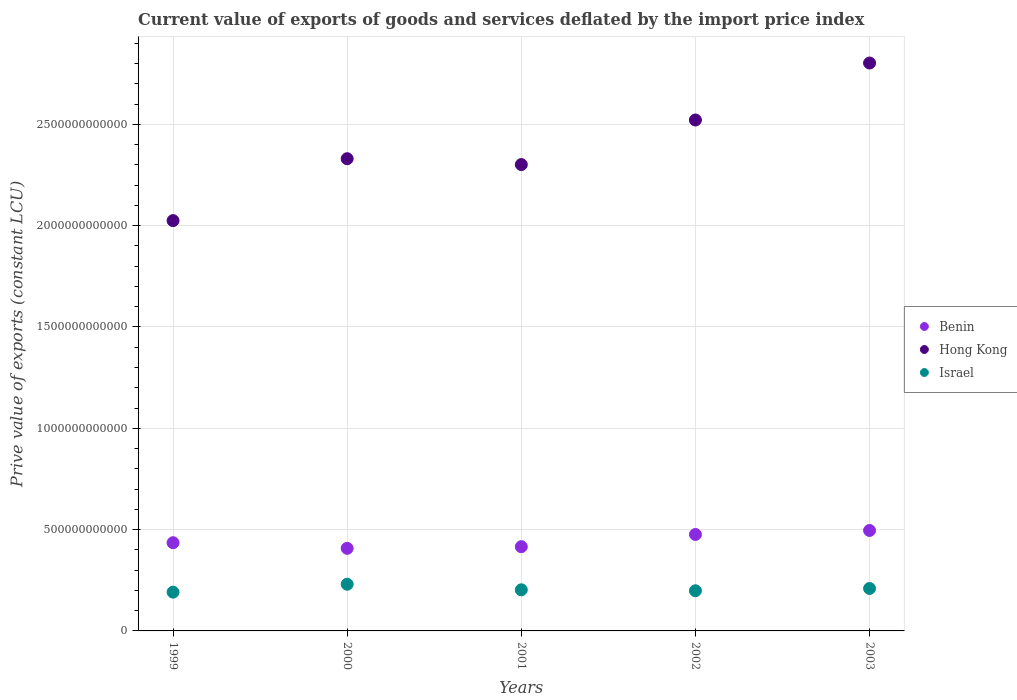What is the prive value of exports in Benin in 2001?
Give a very brief answer. 4.16e+11. Across all years, what is the maximum prive value of exports in Israel?
Offer a very short reply. 2.30e+11. Across all years, what is the minimum prive value of exports in Israel?
Your response must be concise. 1.91e+11. In which year was the prive value of exports in Benin maximum?
Ensure brevity in your answer.  2003. What is the total prive value of exports in Israel in the graph?
Provide a succinct answer. 1.03e+12. What is the difference between the prive value of exports in Benin in 2002 and that in 2003?
Keep it short and to the point. -1.97e+1. What is the difference between the prive value of exports in Hong Kong in 2002 and the prive value of exports in Benin in 2000?
Make the answer very short. 2.11e+12. What is the average prive value of exports in Israel per year?
Keep it short and to the point. 2.06e+11. In the year 2001, what is the difference between the prive value of exports in Hong Kong and prive value of exports in Israel?
Provide a short and direct response. 2.10e+12. In how many years, is the prive value of exports in Hong Kong greater than 2800000000000 LCU?
Your answer should be compact. 1. What is the ratio of the prive value of exports in Benin in 2000 to that in 2003?
Your answer should be compact. 0.82. Is the prive value of exports in Benin in 2000 less than that in 2002?
Your response must be concise. Yes. Is the difference between the prive value of exports in Hong Kong in 1999 and 2003 greater than the difference between the prive value of exports in Israel in 1999 and 2003?
Provide a succinct answer. No. What is the difference between the highest and the second highest prive value of exports in Hong Kong?
Provide a succinct answer. 2.81e+11. What is the difference between the highest and the lowest prive value of exports in Israel?
Provide a short and direct response. 3.90e+1. Is it the case that in every year, the sum of the prive value of exports in Benin and prive value of exports in Israel  is greater than the prive value of exports in Hong Kong?
Offer a terse response. No. Does the prive value of exports in Benin monotonically increase over the years?
Provide a succinct answer. No. Is the prive value of exports in Hong Kong strictly greater than the prive value of exports in Benin over the years?
Provide a succinct answer. Yes. What is the difference between two consecutive major ticks on the Y-axis?
Give a very brief answer. 5.00e+11. Does the graph contain any zero values?
Your response must be concise. No. Does the graph contain grids?
Your answer should be compact. Yes. Where does the legend appear in the graph?
Keep it short and to the point. Center right. How many legend labels are there?
Make the answer very short. 3. How are the legend labels stacked?
Your answer should be very brief. Vertical. What is the title of the graph?
Ensure brevity in your answer.  Current value of exports of goods and services deflated by the import price index. What is the label or title of the X-axis?
Your response must be concise. Years. What is the label or title of the Y-axis?
Your response must be concise. Prive value of exports (constant LCU). What is the Prive value of exports (constant LCU) of Benin in 1999?
Provide a succinct answer. 4.35e+11. What is the Prive value of exports (constant LCU) of Hong Kong in 1999?
Your answer should be compact. 2.02e+12. What is the Prive value of exports (constant LCU) of Israel in 1999?
Your response must be concise. 1.91e+11. What is the Prive value of exports (constant LCU) in Benin in 2000?
Offer a terse response. 4.08e+11. What is the Prive value of exports (constant LCU) in Hong Kong in 2000?
Give a very brief answer. 2.33e+12. What is the Prive value of exports (constant LCU) of Israel in 2000?
Provide a short and direct response. 2.30e+11. What is the Prive value of exports (constant LCU) of Benin in 2001?
Offer a very short reply. 4.16e+11. What is the Prive value of exports (constant LCU) of Hong Kong in 2001?
Offer a very short reply. 2.30e+12. What is the Prive value of exports (constant LCU) in Israel in 2001?
Provide a short and direct response. 2.03e+11. What is the Prive value of exports (constant LCU) in Benin in 2002?
Offer a very short reply. 4.76e+11. What is the Prive value of exports (constant LCU) of Hong Kong in 2002?
Make the answer very short. 2.52e+12. What is the Prive value of exports (constant LCU) of Israel in 2002?
Keep it short and to the point. 1.98e+11. What is the Prive value of exports (constant LCU) of Benin in 2003?
Provide a succinct answer. 4.96e+11. What is the Prive value of exports (constant LCU) in Hong Kong in 2003?
Make the answer very short. 2.80e+12. What is the Prive value of exports (constant LCU) in Israel in 2003?
Offer a terse response. 2.10e+11. Across all years, what is the maximum Prive value of exports (constant LCU) of Benin?
Keep it short and to the point. 4.96e+11. Across all years, what is the maximum Prive value of exports (constant LCU) in Hong Kong?
Provide a succinct answer. 2.80e+12. Across all years, what is the maximum Prive value of exports (constant LCU) in Israel?
Your response must be concise. 2.30e+11. Across all years, what is the minimum Prive value of exports (constant LCU) in Benin?
Your answer should be very brief. 4.08e+11. Across all years, what is the minimum Prive value of exports (constant LCU) in Hong Kong?
Ensure brevity in your answer.  2.02e+12. Across all years, what is the minimum Prive value of exports (constant LCU) in Israel?
Your answer should be very brief. 1.91e+11. What is the total Prive value of exports (constant LCU) of Benin in the graph?
Ensure brevity in your answer.  2.23e+12. What is the total Prive value of exports (constant LCU) in Hong Kong in the graph?
Keep it short and to the point. 1.20e+13. What is the total Prive value of exports (constant LCU) of Israel in the graph?
Offer a very short reply. 1.03e+12. What is the difference between the Prive value of exports (constant LCU) in Benin in 1999 and that in 2000?
Ensure brevity in your answer.  2.77e+1. What is the difference between the Prive value of exports (constant LCU) in Hong Kong in 1999 and that in 2000?
Ensure brevity in your answer.  -3.05e+11. What is the difference between the Prive value of exports (constant LCU) of Israel in 1999 and that in 2000?
Offer a very short reply. -3.90e+1. What is the difference between the Prive value of exports (constant LCU) in Benin in 1999 and that in 2001?
Offer a terse response. 1.96e+1. What is the difference between the Prive value of exports (constant LCU) of Hong Kong in 1999 and that in 2001?
Ensure brevity in your answer.  -2.77e+11. What is the difference between the Prive value of exports (constant LCU) in Israel in 1999 and that in 2001?
Offer a terse response. -1.15e+1. What is the difference between the Prive value of exports (constant LCU) of Benin in 1999 and that in 2002?
Offer a very short reply. -4.07e+1. What is the difference between the Prive value of exports (constant LCU) of Hong Kong in 1999 and that in 2002?
Your answer should be compact. -4.96e+11. What is the difference between the Prive value of exports (constant LCU) in Israel in 1999 and that in 2002?
Make the answer very short. -6.76e+09. What is the difference between the Prive value of exports (constant LCU) in Benin in 1999 and that in 2003?
Offer a very short reply. -6.04e+1. What is the difference between the Prive value of exports (constant LCU) in Hong Kong in 1999 and that in 2003?
Your answer should be very brief. -7.78e+11. What is the difference between the Prive value of exports (constant LCU) of Israel in 1999 and that in 2003?
Give a very brief answer. -1.81e+1. What is the difference between the Prive value of exports (constant LCU) of Benin in 2000 and that in 2001?
Keep it short and to the point. -8.10e+09. What is the difference between the Prive value of exports (constant LCU) in Hong Kong in 2000 and that in 2001?
Give a very brief answer. 2.89e+1. What is the difference between the Prive value of exports (constant LCU) of Israel in 2000 and that in 2001?
Give a very brief answer. 2.75e+1. What is the difference between the Prive value of exports (constant LCU) of Benin in 2000 and that in 2002?
Provide a short and direct response. -6.84e+1. What is the difference between the Prive value of exports (constant LCU) of Hong Kong in 2000 and that in 2002?
Offer a very short reply. -1.91e+11. What is the difference between the Prive value of exports (constant LCU) in Israel in 2000 and that in 2002?
Your answer should be very brief. 3.22e+1. What is the difference between the Prive value of exports (constant LCU) in Benin in 2000 and that in 2003?
Your answer should be very brief. -8.81e+1. What is the difference between the Prive value of exports (constant LCU) of Hong Kong in 2000 and that in 2003?
Your answer should be compact. -4.72e+11. What is the difference between the Prive value of exports (constant LCU) of Israel in 2000 and that in 2003?
Keep it short and to the point. 2.09e+1. What is the difference between the Prive value of exports (constant LCU) in Benin in 2001 and that in 2002?
Provide a short and direct response. -6.03e+1. What is the difference between the Prive value of exports (constant LCU) in Hong Kong in 2001 and that in 2002?
Give a very brief answer. -2.20e+11. What is the difference between the Prive value of exports (constant LCU) in Israel in 2001 and that in 2002?
Make the answer very short. 4.76e+09. What is the difference between the Prive value of exports (constant LCU) in Benin in 2001 and that in 2003?
Keep it short and to the point. -8.00e+1. What is the difference between the Prive value of exports (constant LCU) in Hong Kong in 2001 and that in 2003?
Provide a succinct answer. -5.01e+11. What is the difference between the Prive value of exports (constant LCU) of Israel in 2001 and that in 2003?
Keep it short and to the point. -6.62e+09. What is the difference between the Prive value of exports (constant LCU) of Benin in 2002 and that in 2003?
Provide a succinct answer. -1.97e+1. What is the difference between the Prive value of exports (constant LCU) of Hong Kong in 2002 and that in 2003?
Keep it short and to the point. -2.81e+11. What is the difference between the Prive value of exports (constant LCU) of Israel in 2002 and that in 2003?
Your response must be concise. -1.14e+1. What is the difference between the Prive value of exports (constant LCU) of Benin in 1999 and the Prive value of exports (constant LCU) of Hong Kong in 2000?
Your answer should be compact. -1.89e+12. What is the difference between the Prive value of exports (constant LCU) in Benin in 1999 and the Prive value of exports (constant LCU) in Israel in 2000?
Your answer should be compact. 2.05e+11. What is the difference between the Prive value of exports (constant LCU) in Hong Kong in 1999 and the Prive value of exports (constant LCU) in Israel in 2000?
Provide a short and direct response. 1.79e+12. What is the difference between the Prive value of exports (constant LCU) of Benin in 1999 and the Prive value of exports (constant LCU) of Hong Kong in 2001?
Ensure brevity in your answer.  -1.87e+12. What is the difference between the Prive value of exports (constant LCU) of Benin in 1999 and the Prive value of exports (constant LCU) of Israel in 2001?
Your answer should be compact. 2.32e+11. What is the difference between the Prive value of exports (constant LCU) of Hong Kong in 1999 and the Prive value of exports (constant LCU) of Israel in 2001?
Your answer should be compact. 1.82e+12. What is the difference between the Prive value of exports (constant LCU) in Benin in 1999 and the Prive value of exports (constant LCU) in Hong Kong in 2002?
Offer a terse response. -2.09e+12. What is the difference between the Prive value of exports (constant LCU) in Benin in 1999 and the Prive value of exports (constant LCU) in Israel in 2002?
Give a very brief answer. 2.37e+11. What is the difference between the Prive value of exports (constant LCU) in Hong Kong in 1999 and the Prive value of exports (constant LCU) in Israel in 2002?
Offer a very short reply. 1.83e+12. What is the difference between the Prive value of exports (constant LCU) in Benin in 1999 and the Prive value of exports (constant LCU) in Hong Kong in 2003?
Make the answer very short. -2.37e+12. What is the difference between the Prive value of exports (constant LCU) of Benin in 1999 and the Prive value of exports (constant LCU) of Israel in 2003?
Provide a short and direct response. 2.26e+11. What is the difference between the Prive value of exports (constant LCU) of Hong Kong in 1999 and the Prive value of exports (constant LCU) of Israel in 2003?
Your answer should be very brief. 1.82e+12. What is the difference between the Prive value of exports (constant LCU) in Benin in 2000 and the Prive value of exports (constant LCU) in Hong Kong in 2001?
Make the answer very short. -1.89e+12. What is the difference between the Prive value of exports (constant LCU) in Benin in 2000 and the Prive value of exports (constant LCU) in Israel in 2001?
Offer a very short reply. 2.05e+11. What is the difference between the Prive value of exports (constant LCU) of Hong Kong in 2000 and the Prive value of exports (constant LCU) of Israel in 2001?
Provide a succinct answer. 2.13e+12. What is the difference between the Prive value of exports (constant LCU) of Benin in 2000 and the Prive value of exports (constant LCU) of Hong Kong in 2002?
Your answer should be compact. -2.11e+12. What is the difference between the Prive value of exports (constant LCU) in Benin in 2000 and the Prive value of exports (constant LCU) in Israel in 2002?
Give a very brief answer. 2.09e+11. What is the difference between the Prive value of exports (constant LCU) in Hong Kong in 2000 and the Prive value of exports (constant LCU) in Israel in 2002?
Offer a terse response. 2.13e+12. What is the difference between the Prive value of exports (constant LCU) in Benin in 2000 and the Prive value of exports (constant LCU) in Hong Kong in 2003?
Your response must be concise. -2.39e+12. What is the difference between the Prive value of exports (constant LCU) in Benin in 2000 and the Prive value of exports (constant LCU) in Israel in 2003?
Give a very brief answer. 1.98e+11. What is the difference between the Prive value of exports (constant LCU) in Hong Kong in 2000 and the Prive value of exports (constant LCU) in Israel in 2003?
Offer a very short reply. 2.12e+12. What is the difference between the Prive value of exports (constant LCU) of Benin in 2001 and the Prive value of exports (constant LCU) of Hong Kong in 2002?
Your answer should be compact. -2.11e+12. What is the difference between the Prive value of exports (constant LCU) of Benin in 2001 and the Prive value of exports (constant LCU) of Israel in 2002?
Provide a succinct answer. 2.18e+11. What is the difference between the Prive value of exports (constant LCU) in Hong Kong in 2001 and the Prive value of exports (constant LCU) in Israel in 2002?
Make the answer very short. 2.10e+12. What is the difference between the Prive value of exports (constant LCU) in Benin in 2001 and the Prive value of exports (constant LCU) in Hong Kong in 2003?
Offer a terse response. -2.39e+12. What is the difference between the Prive value of exports (constant LCU) in Benin in 2001 and the Prive value of exports (constant LCU) in Israel in 2003?
Your answer should be compact. 2.06e+11. What is the difference between the Prive value of exports (constant LCU) of Hong Kong in 2001 and the Prive value of exports (constant LCU) of Israel in 2003?
Make the answer very short. 2.09e+12. What is the difference between the Prive value of exports (constant LCU) in Benin in 2002 and the Prive value of exports (constant LCU) in Hong Kong in 2003?
Provide a succinct answer. -2.33e+12. What is the difference between the Prive value of exports (constant LCU) in Benin in 2002 and the Prive value of exports (constant LCU) in Israel in 2003?
Provide a short and direct response. 2.66e+11. What is the difference between the Prive value of exports (constant LCU) in Hong Kong in 2002 and the Prive value of exports (constant LCU) in Israel in 2003?
Ensure brevity in your answer.  2.31e+12. What is the average Prive value of exports (constant LCU) in Benin per year?
Keep it short and to the point. 4.46e+11. What is the average Prive value of exports (constant LCU) in Hong Kong per year?
Ensure brevity in your answer.  2.40e+12. What is the average Prive value of exports (constant LCU) in Israel per year?
Your answer should be compact. 2.06e+11. In the year 1999, what is the difference between the Prive value of exports (constant LCU) in Benin and Prive value of exports (constant LCU) in Hong Kong?
Offer a terse response. -1.59e+12. In the year 1999, what is the difference between the Prive value of exports (constant LCU) in Benin and Prive value of exports (constant LCU) in Israel?
Your response must be concise. 2.44e+11. In the year 1999, what is the difference between the Prive value of exports (constant LCU) in Hong Kong and Prive value of exports (constant LCU) in Israel?
Keep it short and to the point. 1.83e+12. In the year 2000, what is the difference between the Prive value of exports (constant LCU) of Benin and Prive value of exports (constant LCU) of Hong Kong?
Your response must be concise. -1.92e+12. In the year 2000, what is the difference between the Prive value of exports (constant LCU) in Benin and Prive value of exports (constant LCU) in Israel?
Provide a short and direct response. 1.77e+11. In the year 2000, what is the difference between the Prive value of exports (constant LCU) in Hong Kong and Prive value of exports (constant LCU) in Israel?
Offer a very short reply. 2.10e+12. In the year 2001, what is the difference between the Prive value of exports (constant LCU) of Benin and Prive value of exports (constant LCU) of Hong Kong?
Offer a very short reply. -1.89e+12. In the year 2001, what is the difference between the Prive value of exports (constant LCU) of Benin and Prive value of exports (constant LCU) of Israel?
Give a very brief answer. 2.13e+11. In the year 2001, what is the difference between the Prive value of exports (constant LCU) in Hong Kong and Prive value of exports (constant LCU) in Israel?
Keep it short and to the point. 2.10e+12. In the year 2002, what is the difference between the Prive value of exports (constant LCU) of Benin and Prive value of exports (constant LCU) of Hong Kong?
Make the answer very short. -2.05e+12. In the year 2002, what is the difference between the Prive value of exports (constant LCU) in Benin and Prive value of exports (constant LCU) in Israel?
Offer a terse response. 2.78e+11. In the year 2002, what is the difference between the Prive value of exports (constant LCU) in Hong Kong and Prive value of exports (constant LCU) in Israel?
Keep it short and to the point. 2.32e+12. In the year 2003, what is the difference between the Prive value of exports (constant LCU) of Benin and Prive value of exports (constant LCU) of Hong Kong?
Offer a terse response. -2.31e+12. In the year 2003, what is the difference between the Prive value of exports (constant LCU) of Benin and Prive value of exports (constant LCU) of Israel?
Your answer should be very brief. 2.86e+11. In the year 2003, what is the difference between the Prive value of exports (constant LCU) in Hong Kong and Prive value of exports (constant LCU) in Israel?
Keep it short and to the point. 2.59e+12. What is the ratio of the Prive value of exports (constant LCU) of Benin in 1999 to that in 2000?
Your answer should be compact. 1.07. What is the ratio of the Prive value of exports (constant LCU) in Hong Kong in 1999 to that in 2000?
Give a very brief answer. 0.87. What is the ratio of the Prive value of exports (constant LCU) of Israel in 1999 to that in 2000?
Ensure brevity in your answer.  0.83. What is the ratio of the Prive value of exports (constant LCU) of Benin in 1999 to that in 2001?
Offer a terse response. 1.05. What is the ratio of the Prive value of exports (constant LCU) in Hong Kong in 1999 to that in 2001?
Your response must be concise. 0.88. What is the ratio of the Prive value of exports (constant LCU) in Israel in 1999 to that in 2001?
Ensure brevity in your answer.  0.94. What is the ratio of the Prive value of exports (constant LCU) in Benin in 1999 to that in 2002?
Offer a very short reply. 0.91. What is the ratio of the Prive value of exports (constant LCU) of Hong Kong in 1999 to that in 2002?
Your answer should be compact. 0.8. What is the ratio of the Prive value of exports (constant LCU) in Israel in 1999 to that in 2002?
Give a very brief answer. 0.97. What is the ratio of the Prive value of exports (constant LCU) of Benin in 1999 to that in 2003?
Your answer should be very brief. 0.88. What is the ratio of the Prive value of exports (constant LCU) of Hong Kong in 1999 to that in 2003?
Keep it short and to the point. 0.72. What is the ratio of the Prive value of exports (constant LCU) in Israel in 1999 to that in 2003?
Your answer should be compact. 0.91. What is the ratio of the Prive value of exports (constant LCU) of Benin in 2000 to that in 2001?
Offer a terse response. 0.98. What is the ratio of the Prive value of exports (constant LCU) in Hong Kong in 2000 to that in 2001?
Keep it short and to the point. 1.01. What is the ratio of the Prive value of exports (constant LCU) in Israel in 2000 to that in 2001?
Provide a succinct answer. 1.14. What is the ratio of the Prive value of exports (constant LCU) of Benin in 2000 to that in 2002?
Offer a very short reply. 0.86. What is the ratio of the Prive value of exports (constant LCU) of Hong Kong in 2000 to that in 2002?
Offer a terse response. 0.92. What is the ratio of the Prive value of exports (constant LCU) of Israel in 2000 to that in 2002?
Your answer should be very brief. 1.16. What is the ratio of the Prive value of exports (constant LCU) of Benin in 2000 to that in 2003?
Make the answer very short. 0.82. What is the ratio of the Prive value of exports (constant LCU) of Hong Kong in 2000 to that in 2003?
Provide a succinct answer. 0.83. What is the ratio of the Prive value of exports (constant LCU) in Israel in 2000 to that in 2003?
Your response must be concise. 1.1. What is the ratio of the Prive value of exports (constant LCU) of Benin in 2001 to that in 2002?
Your response must be concise. 0.87. What is the ratio of the Prive value of exports (constant LCU) in Hong Kong in 2001 to that in 2002?
Provide a short and direct response. 0.91. What is the ratio of the Prive value of exports (constant LCU) in Benin in 2001 to that in 2003?
Provide a short and direct response. 0.84. What is the ratio of the Prive value of exports (constant LCU) of Hong Kong in 2001 to that in 2003?
Make the answer very short. 0.82. What is the ratio of the Prive value of exports (constant LCU) in Israel in 2001 to that in 2003?
Provide a succinct answer. 0.97. What is the ratio of the Prive value of exports (constant LCU) in Benin in 2002 to that in 2003?
Provide a short and direct response. 0.96. What is the ratio of the Prive value of exports (constant LCU) in Hong Kong in 2002 to that in 2003?
Your answer should be compact. 0.9. What is the ratio of the Prive value of exports (constant LCU) in Israel in 2002 to that in 2003?
Ensure brevity in your answer.  0.95. What is the difference between the highest and the second highest Prive value of exports (constant LCU) of Benin?
Keep it short and to the point. 1.97e+1. What is the difference between the highest and the second highest Prive value of exports (constant LCU) in Hong Kong?
Provide a succinct answer. 2.81e+11. What is the difference between the highest and the second highest Prive value of exports (constant LCU) of Israel?
Make the answer very short. 2.09e+1. What is the difference between the highest and the lowest Prive value of exports (constant LCU) in Benin?
Provide a succinct answer. 8.81e+1. What is the difference between the highest and the lowest Prive value of exports (constant LCU) of Hong Kong?
Provide a short and direct response. 7.78e+11. What is the difference between the highest and the lowest Prive value of exports (constant LCU) of Israel?
Offer a very short reply. 3.90e+1. 